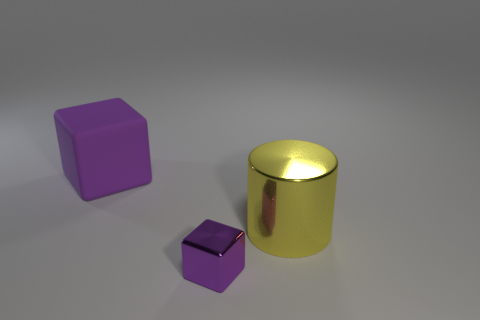Add 3 large metal spheres. How many objects exist? 6 Add 1 rubber objects. How many rubber objects are left? 2 Add 1 large gray balls. How many large gray balls exist? 1 Subtract 0 cyan spheres. How many objects are left? 3 Subtract all cylinders. How many objects are left? 2 Subtract 1 cylinders. How many cylinders are left? 0 Subtract all yellow blocks. Subtract all yellow balls. How many blocks are left? 2 Subtract all yellow balls. How many brown blocks are left? 0 Subtract all tiny cubes. Subtract all big purple blocks. How many objects are left? 1 